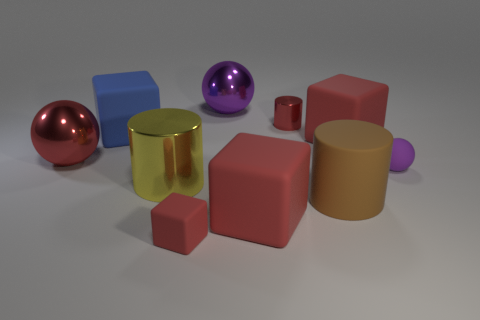Subtract all red cubes. How many were subtracted if there are1red cubes left? 2 Subtract all cyan balls. How many red cubes are left? 3 Subtract 1 blocks. How many blocks are left? 3 Subtract all balls. How many objects are left? 7 Subtract all big red blocks. Subtract all large blue rubber things. How many objects are left? 7 Add 9 big blue cubes. How many big blue cubes are left? 10 Add 6 tiny metallic cylinders. How many tiny metallic cylinders exist? 7 Subtract 0 green cubes. How many objects are left? 10 